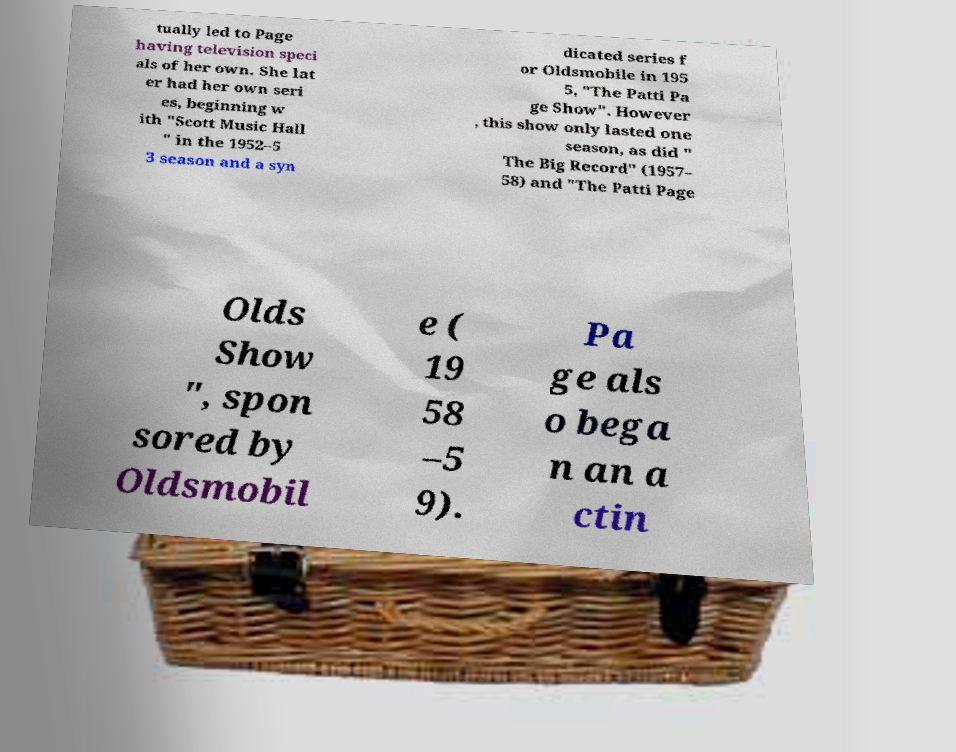What messages or text are displayed in this image? I need them in a readable, typed format. tually led to Page having television speci als of her own. She lat er had her own seri es, beginning w ith "Scott Music Hall " in the 1952–5 3 season and a syn dicated series f or Oldsmobile in 195 5, "The Patti Pa ge Show". However , this show only lasted one season, as did " The Big Record" (1957– 58) and "The Patti Page Olds Show ", spon sored by Oldsmobil e ( 19 58 –5 9). Pa ge als o bega n an a ctin 